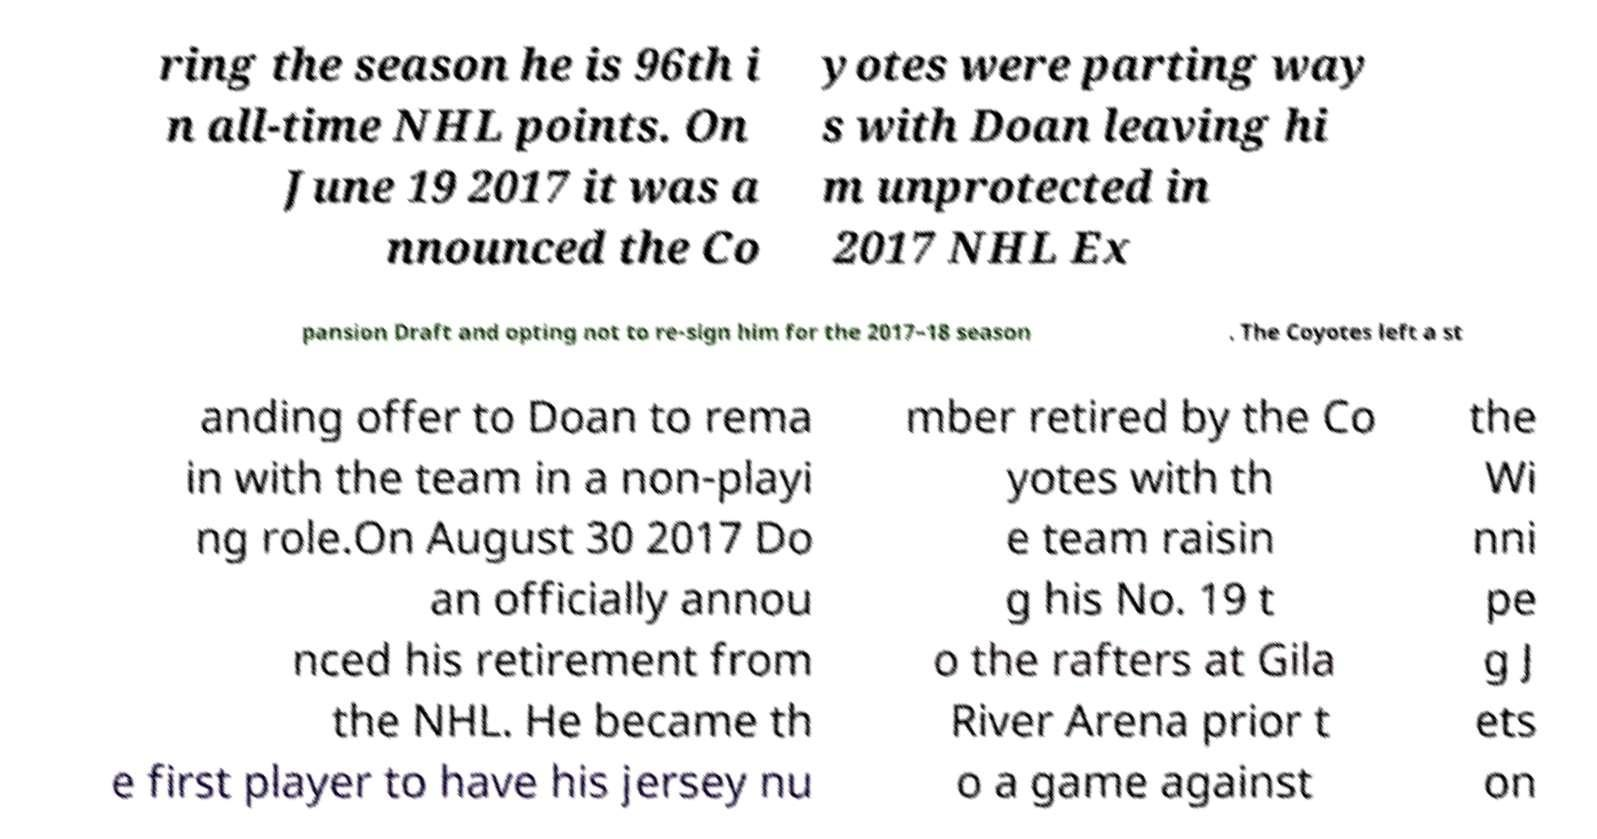Could you extract and type out the text from this image? ring the season he is 96th i n all-time NHL points. On June 19 2017 it was a nnounced the Co yotes were parting way s with Doan leaving hi m unprotected in 2017 NHL Ex pansion Draft and opting not to re-sign him for the 2017–18 season . The Coyotes left a st anding offer to Doan to rema in with the team in a non-playi ng role.On August 30 2017 Do an officially annou nced his retirement from the NHL. He became th e first player to have his jersey nu mber retired by the Co yotes with th e team raisin g his No. 19 t o the rafters at Gila River Arena prior t o a game against the Wi nni pe g J ets on 